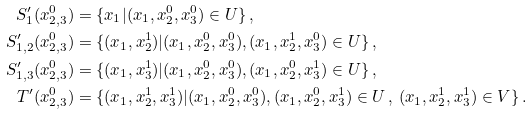Convert formula to latex. <formula><loc_0><loc_0><loc_500><loc_500>S _ { 1 } ^ { \prime } ( x _ { 2 , 3 } ^ { 0 } ) & = \{ x _ { 1 } | ( x _ { 1 } , x _ { 2 } ^ { 0 } , x _ { 3 } ^ { 0 } ) \in U \} \, , \\ S _ { 1 , 2 } ^ { \prime } ( x _ { 2 , 3 } ^ { 0 } ) & = \{ ( x _ { 1 } , x _ { 2 } ^ { 1 } ) | ( x _ { 1 } , x _ { 2 } ^ { 0 } , x _ { 3 } ^ { 0 } ) , ( x _ { 1 } , x _ { 2 } ^ { 1 } , x _ { 3 } ^ { 0 } ) \in U \} \, , \\ S _ { 1 , 3 } ^ { \prime } ( x _ { 2 , 3 } ^ { 0 } ) & = \{ ( x _ { 1 } , x _ { 3 } ^ { 1 } ) | ( x _ { 1 } , x _ { 2 } ^ { 0 } , x _ { 3 } ^ { 0 } ) , ( x _ { 1 } , x _ { 2 } ^ { 0 } , x _ { 3 } ^ { 1 } ) \in U \} \, , \\ T ^ { \prime } ( x _ { 2 , 3 } ^ { 0 } ) & = \{ ( x _ { 1 } , x _ { 2 } ^ { 1 } , x _ { 3 } ^ { 1 } ) | ( x _ { 1 } , x _ { 2 } ^ { 0 } , x _ { 3 } ^ { 0 } ) , ( x _ { 1 } , x _ { 2 } ^ { 0 } , x _ { 3 } ^ { 1 } ) \in U \, , \, ( x _ { 1 } , x _ { 2 } ^ { 1 } , x _ { 3 } ^ { 1 } ) \in V \} \, .</formula> 